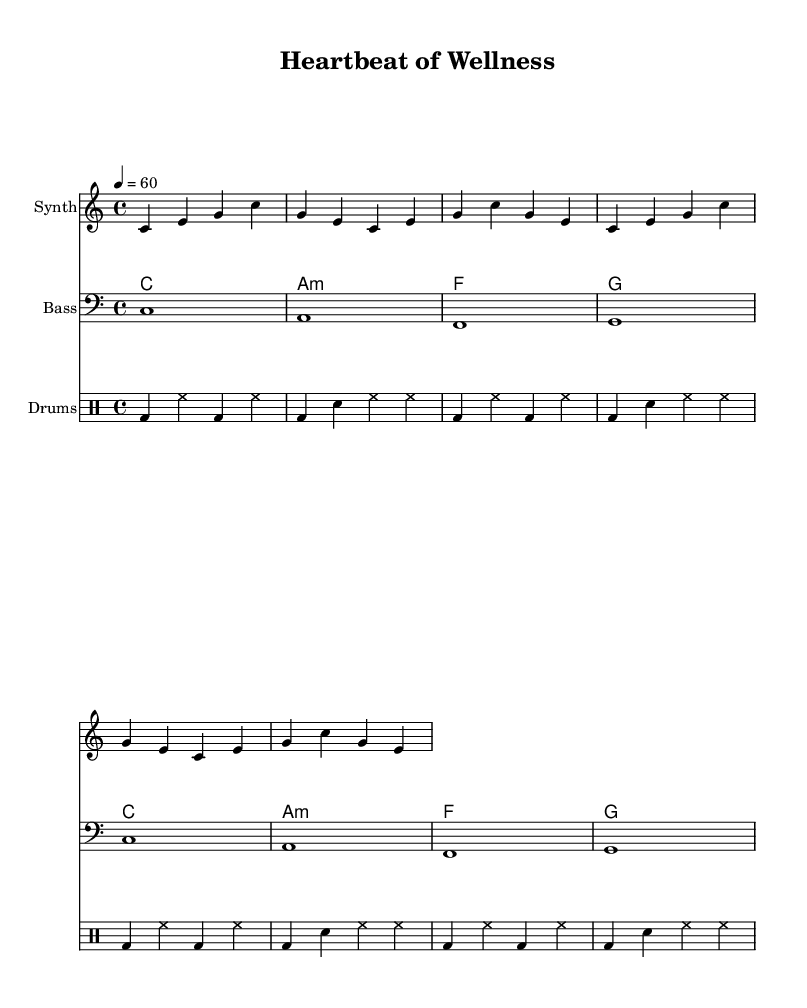What is the key signature of this music? The key signature is C major, which has no sharps or flats.
Answer: C major What is the time signature of this piece? The time signature is indicated as 4/4, meaning there are four beats in each measure.
Answer: 4/4 What is the tempo marking for this music? The tempo indicates a speed of 60 beats per minute, represented by the marking "4 = 60".
Answer: 60 How many measures are in the synth melody? The synth melody consists of four measures, which can be counted in the repeated rhythm and note pattern.
Answer: 4 What is the primary rhythmic element used in the drum patterns? The primary rhythmic element is a combination of bass drum and hi-hat patterns, creating a consistent beat throughout the measures.
Answer: Bass drum and hi-hat What chord appears most frequently in the composition? The chord C major appears most frequently, as it is played in each measure, establishing the tonal center.
Answer: C major How many different instruments are represented in the score? There are four different instruments represented in the score: Synth, Bass, Chords, and Drums.
Answer: Four 